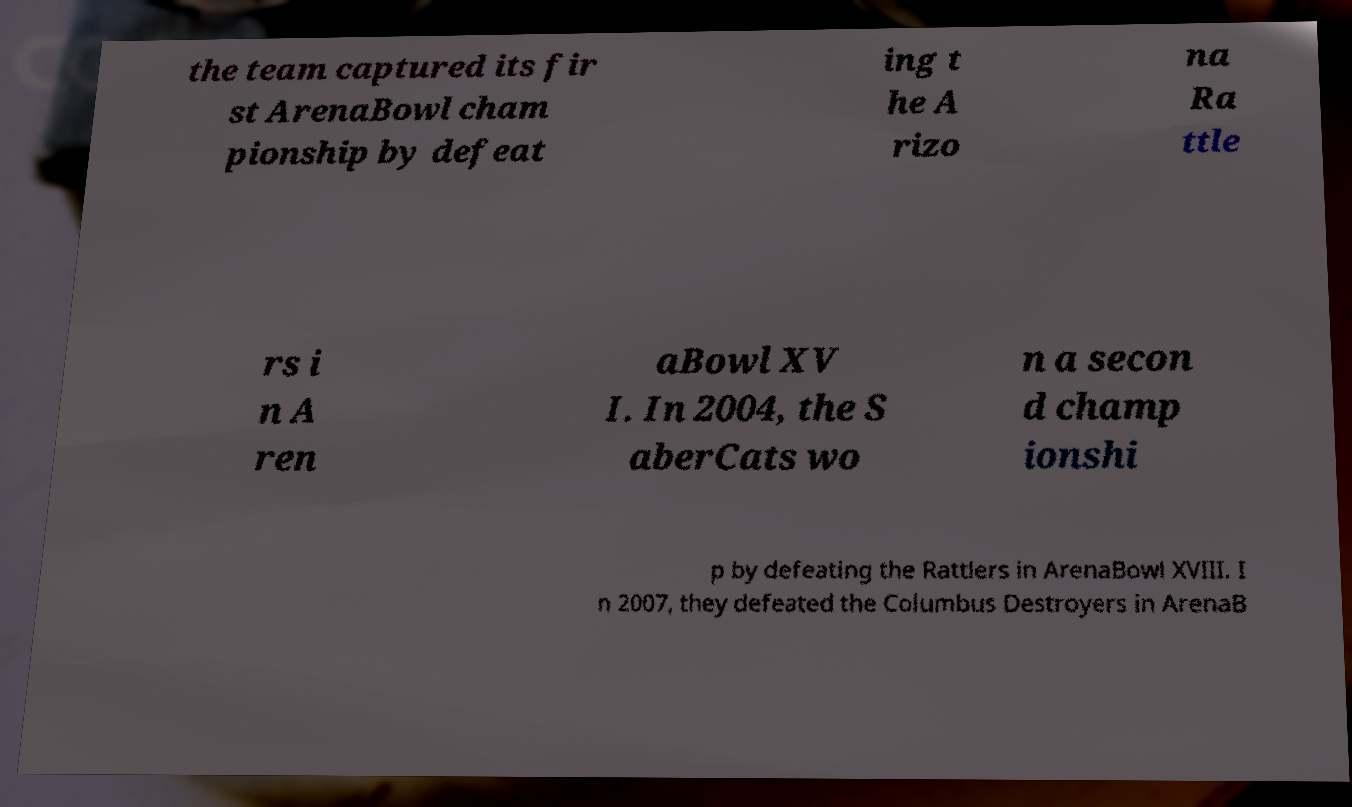Please read and relay the text visible in this image. What does it say? the team captured its fir st ArenaBowl cham pionship by defeat ing t he A rizo na Ra ttle rs i n A ren aBowl XV I. In 2004, the S aberCats wo n a secon d champ ionshi p by defeating the Rattlers in ArenaBowl XVIII. I n 2007, they defeated the Columbus Destroyers in ArenaB 